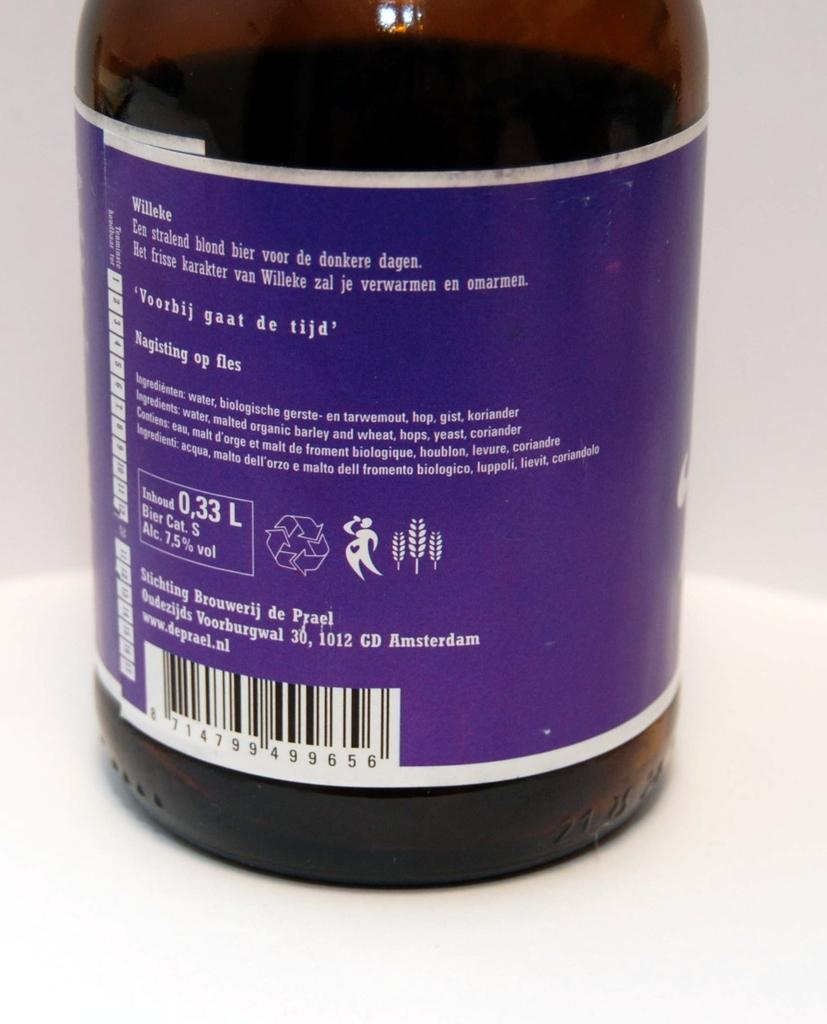What object can be seen in the image? There is a bottle in the image. Where is the bottle located? The bottle is on a table. How does the bottle contribute to peace in the image? The image does not depict any elements related to peace, and the presence of a bottle does not inherently contribute to peace. 